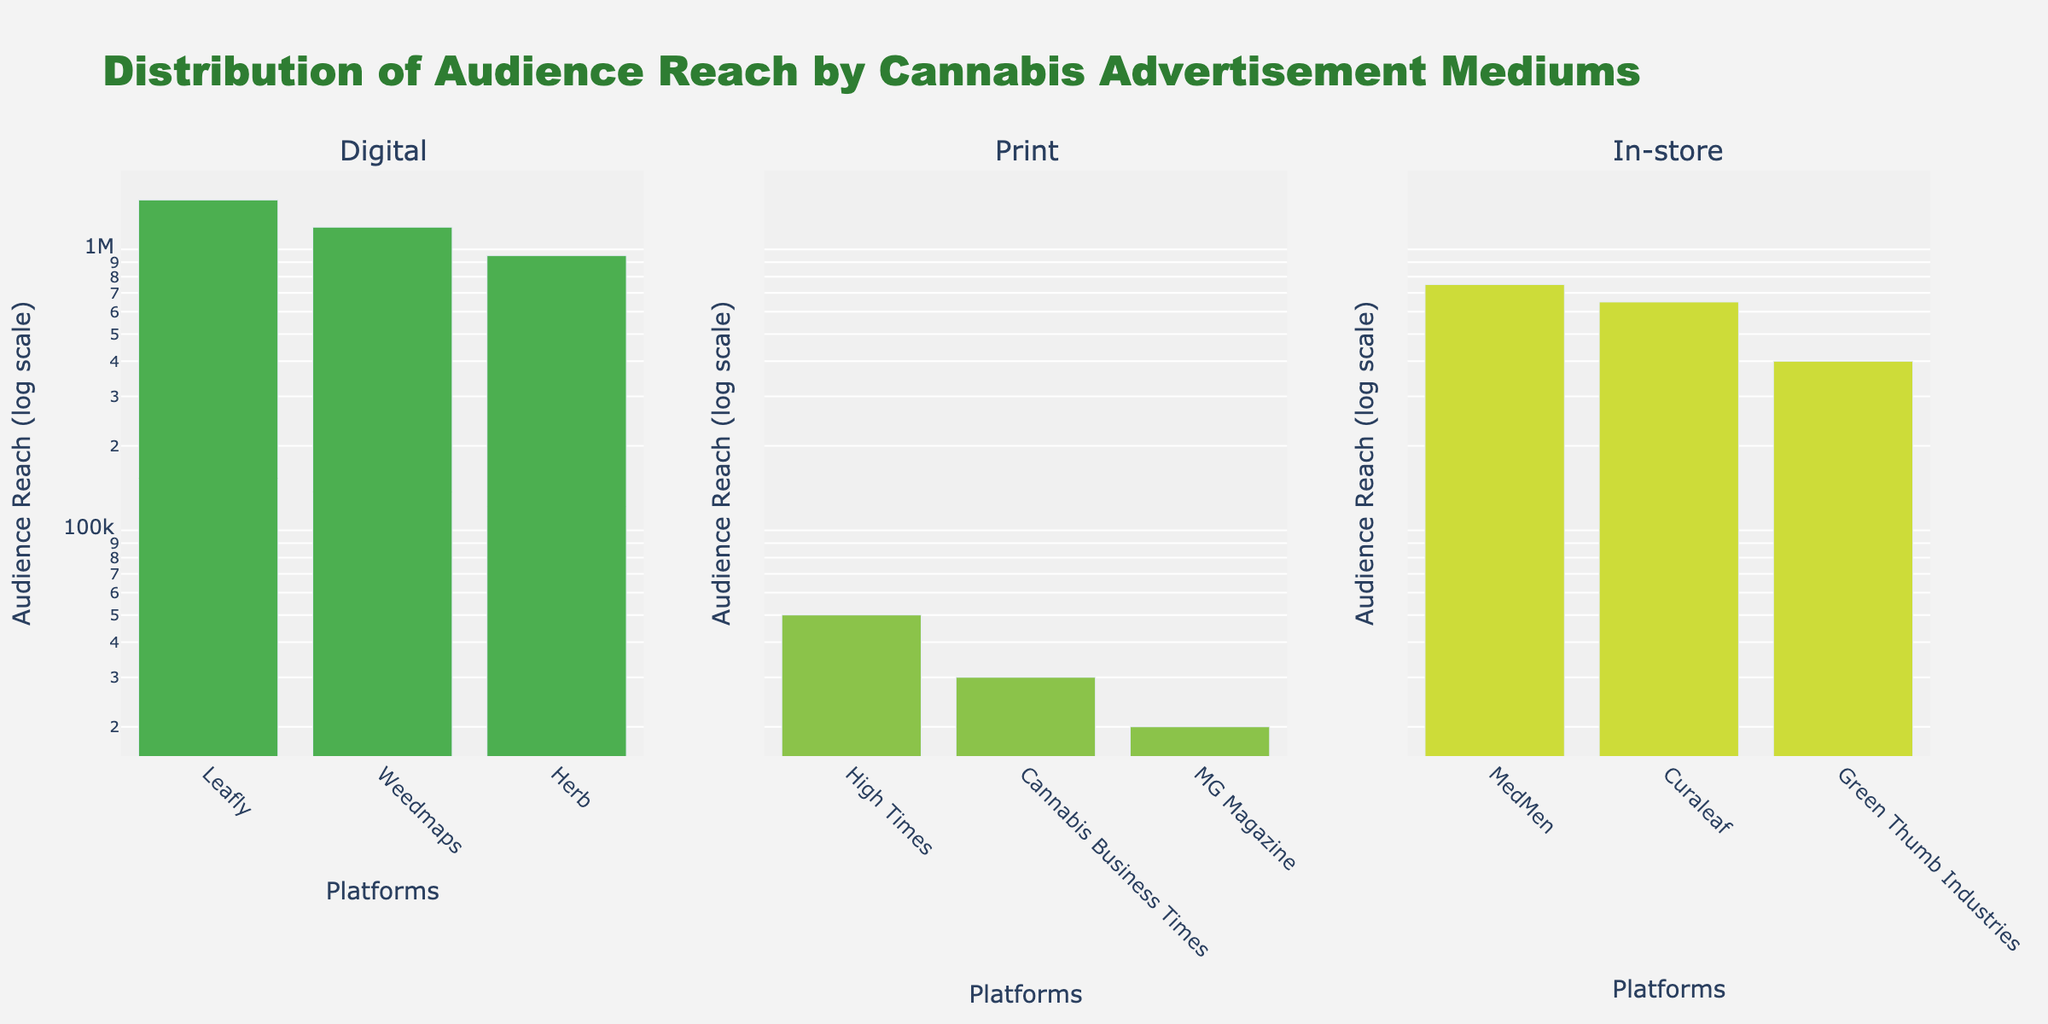What is the title of the subplot chart? The title of a chart is typically displayed at the top of the figure. In this case, it is clearly visible and readable.
Answer: Distribution of Audience Reach by Cannabis Advertisement Mediums Which advertising medium has the highest audience reach? To determine this, check the highest bars in each of the three subplots. The tallest bar overall belongs to the "Digital" medium, specifically "Leafly."
Answer: Digital How many advertising entities are shown for each medium? Count the number of bars within each subplot. Each subplot represents an advertising medium and contains multiple bars representing different entities. Each subplot has 3 entities.
Answer: 3 entities each What is the audience reach of "MedMen" in the in-store medium? Look at the bar corresponding to "MedMen" in the in-store subplot. The bar's height and the accompanying annotation both indicate the number.
Answer: 750,000 What is the difference in audience reach between Leafly and Weedmaps? Identify the bars representing Leafly and Weedmaps in the Digital subplot. Subtract the reach of Weedmaps from Leafly (1,500,000 - 1,200,000).
Answer: 300,000 Which print ad platform has the lowest audience reach? In the print subplot, check the heights of the bars. The shortest bar belongs to "MG Magazine."
Answer: MG Magazine How much greater is the audience reach of Leafly compared to High Times? Look at the bars for Leafly in the Digital subplot and High Times in the Print subplot. Subtract the reach of High Times from Leafly (1,500,000 - 50,000).
Answer: 1,450,000 Are there more entities in digital advertising or print advertising? Count the bars in both the Digital and Print subplots. Each has the same number of entities.
Answer: They are equal What is the average audience reach for in-store advertising entities? Sum the audience reach of MedMen, Curaleaf, and Green Thumb Industries. Divide by the number of entities (750,000 + 650,000 + 400,000) / 3.
Answer: 600,000 Which advertising medium has the lowest overall audience reach? Sum the heights of all the bars for each medium. Print has the lowest overall audience reach with a total of 100,000 (50,000 + 30,000 + 20,000).
Answer: Print 